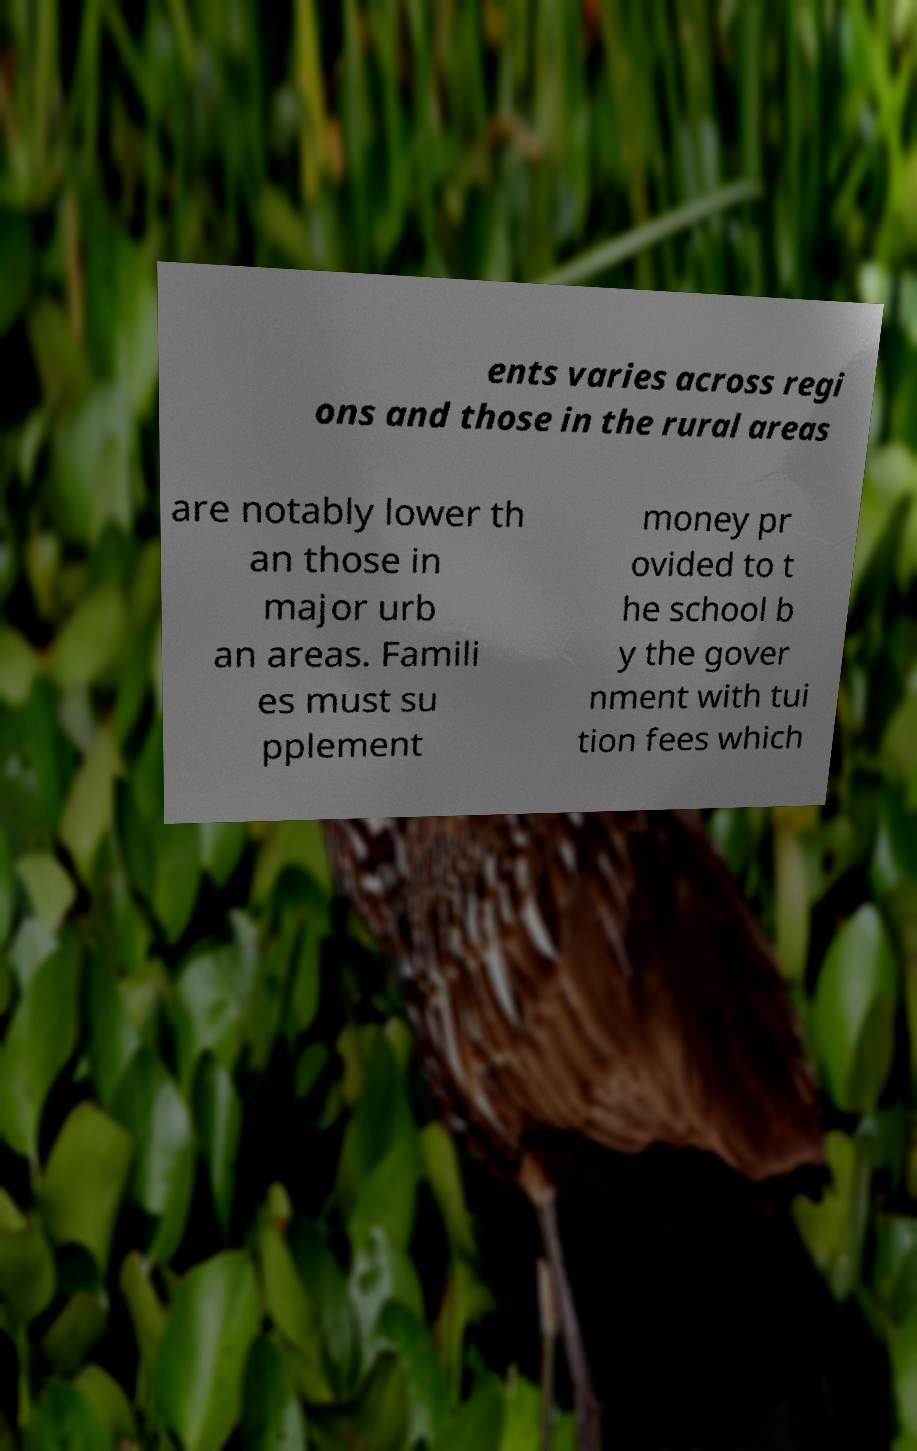There's text embedded in this image that I need extracted. Can you transcribe it verbatim? ents varies across regi ons and those in the rural areas are notably lower th an those in major urb an areas. Famili es must su pplement money pr ovided to t he school b y the gover nment with tui tion fees which 